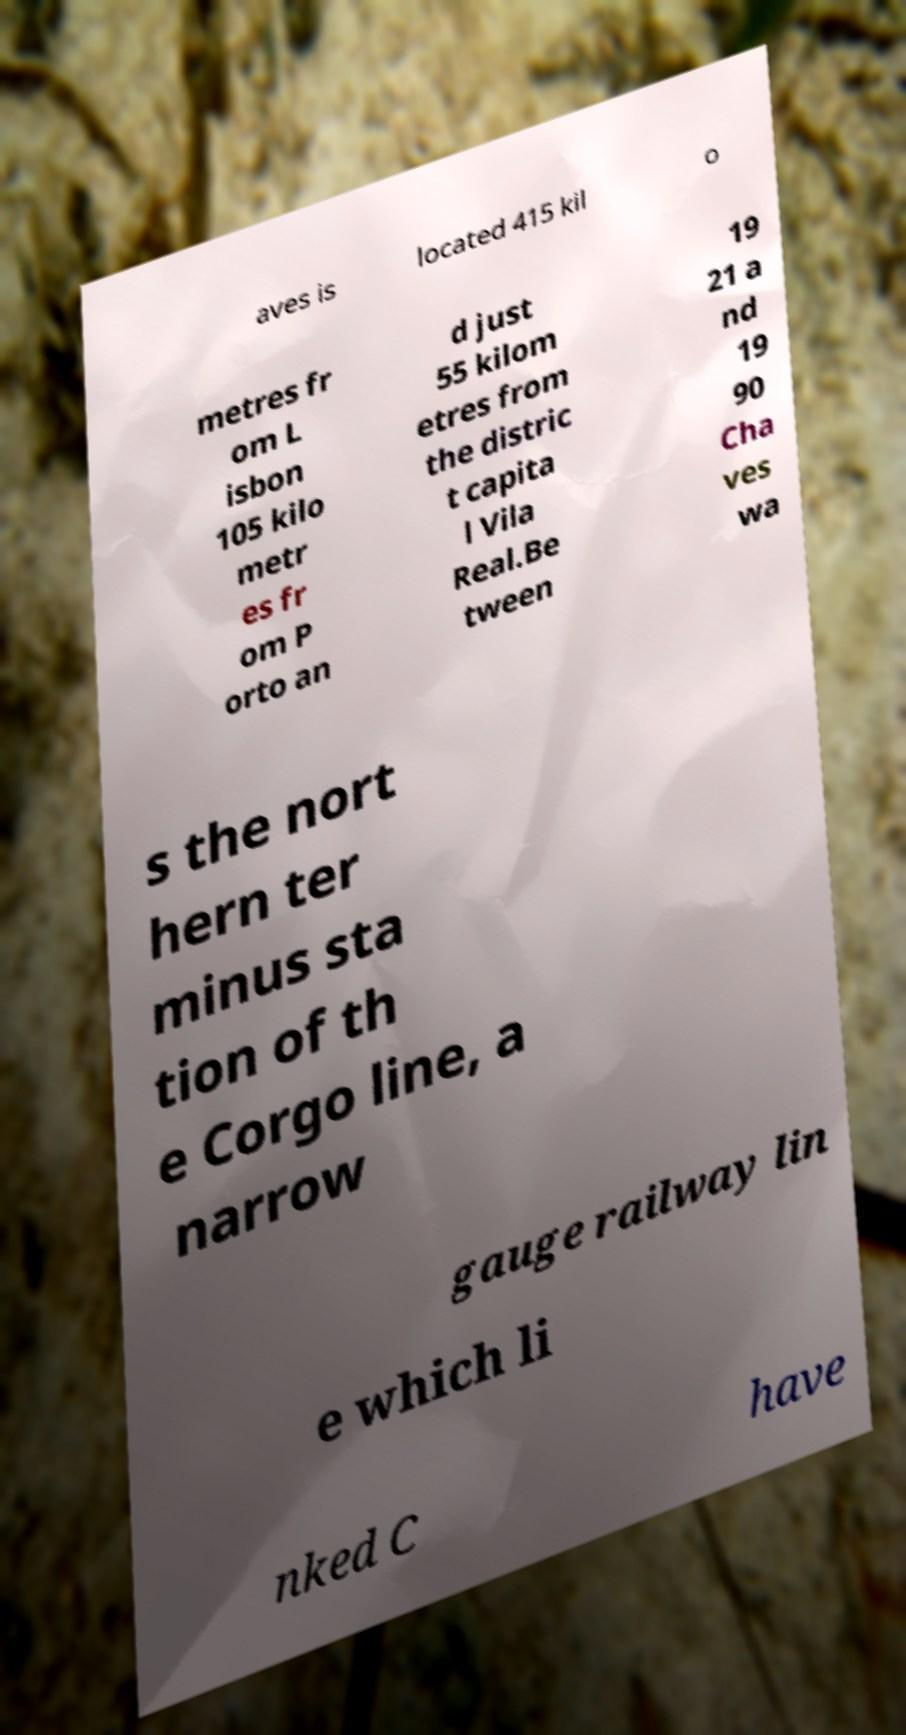There's text embedded in this image that I need extracted. Can you transcribe it verbatim? aves is located 415 kil o metres fr om L isbon 105 kilo metr es fr om P orto an d just 55 kilom etres from the distric t capita l Vila Real.Be tween 19 21 a nd 19 90 Cha ves wa s the nort hern ter minus sta tion of th e Corgo line, a narrow gauge railway lin e which li nked C have 